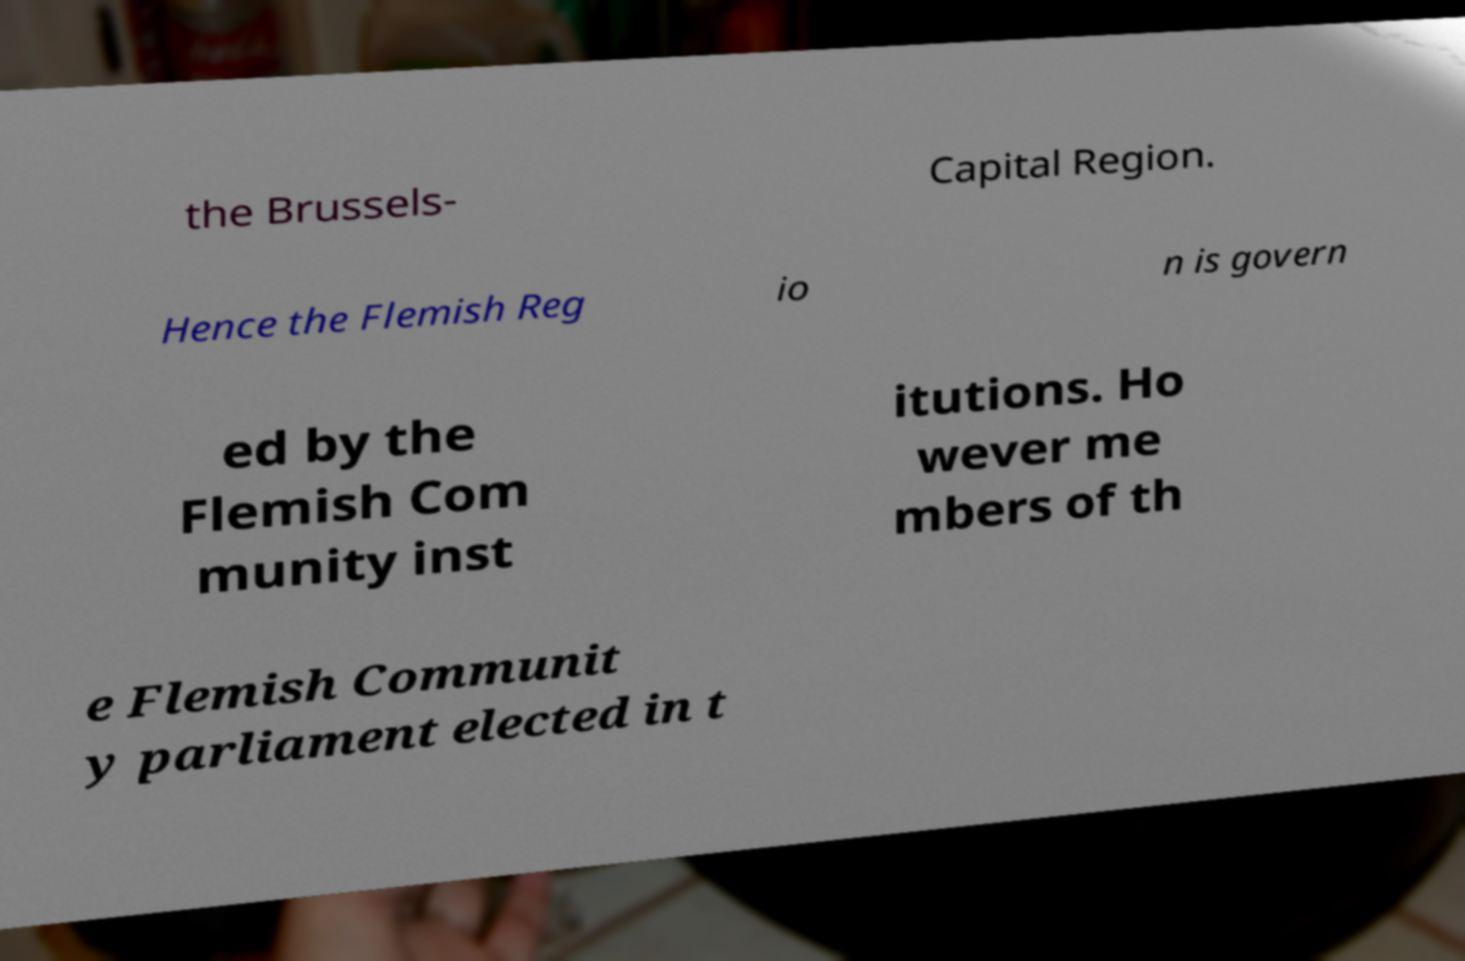There's text embedded in this image that I need extracted. Can you transcribe it verbatim? the Brussels- Capital Region. Hence the Flemish Reg io n is govern ed by the Flemish Com munity inst itutions. Ho wever me mbers of th e Flemish Communit y parliament elected in t 